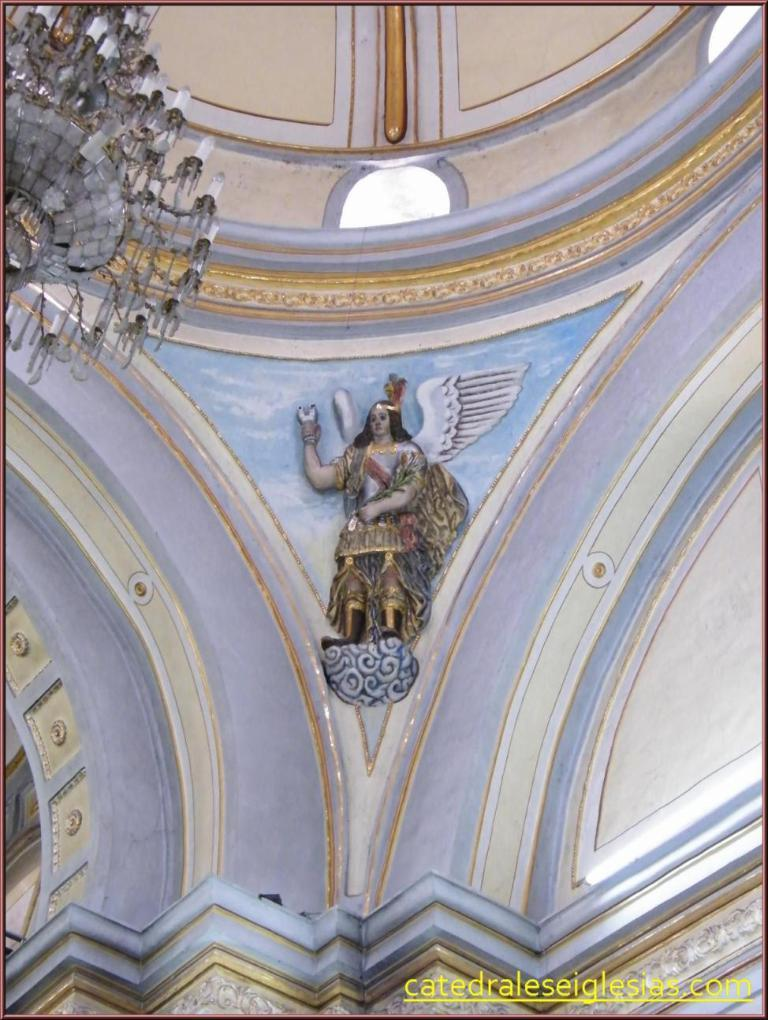What is the main subject of the image? There is an art piece in the middle of the image. What is written or depicted at the bottom of the image? There is text at the bottom of the image. Where was the image taken? The image was taken inside a building. What type of lighting fixture can be seen on the left side of the image? There is a chandelier on the left side of the image. What type of can is visible in the image? There is no can present in the image. What type of furniture can be seen supporting the art piece in the image? The provided facts do not mention any furniture supporting the art piece. 